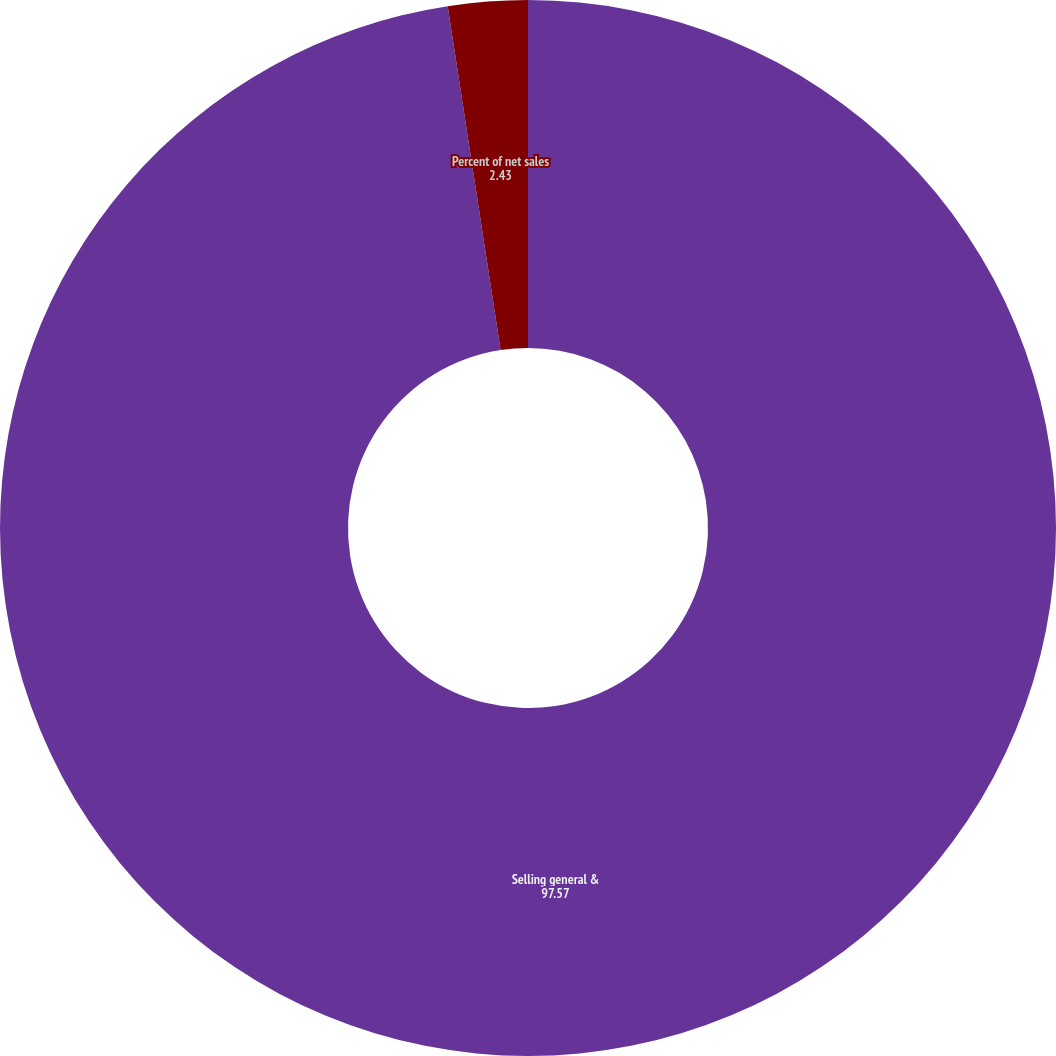<chart> <loc_0><loc_0><loc_500><loc_500><pie_chart><fcel>Selling general &<fcel>Percent of net sales<nl><fcel>97.57%<fcel>2.43%<nl></chart> 